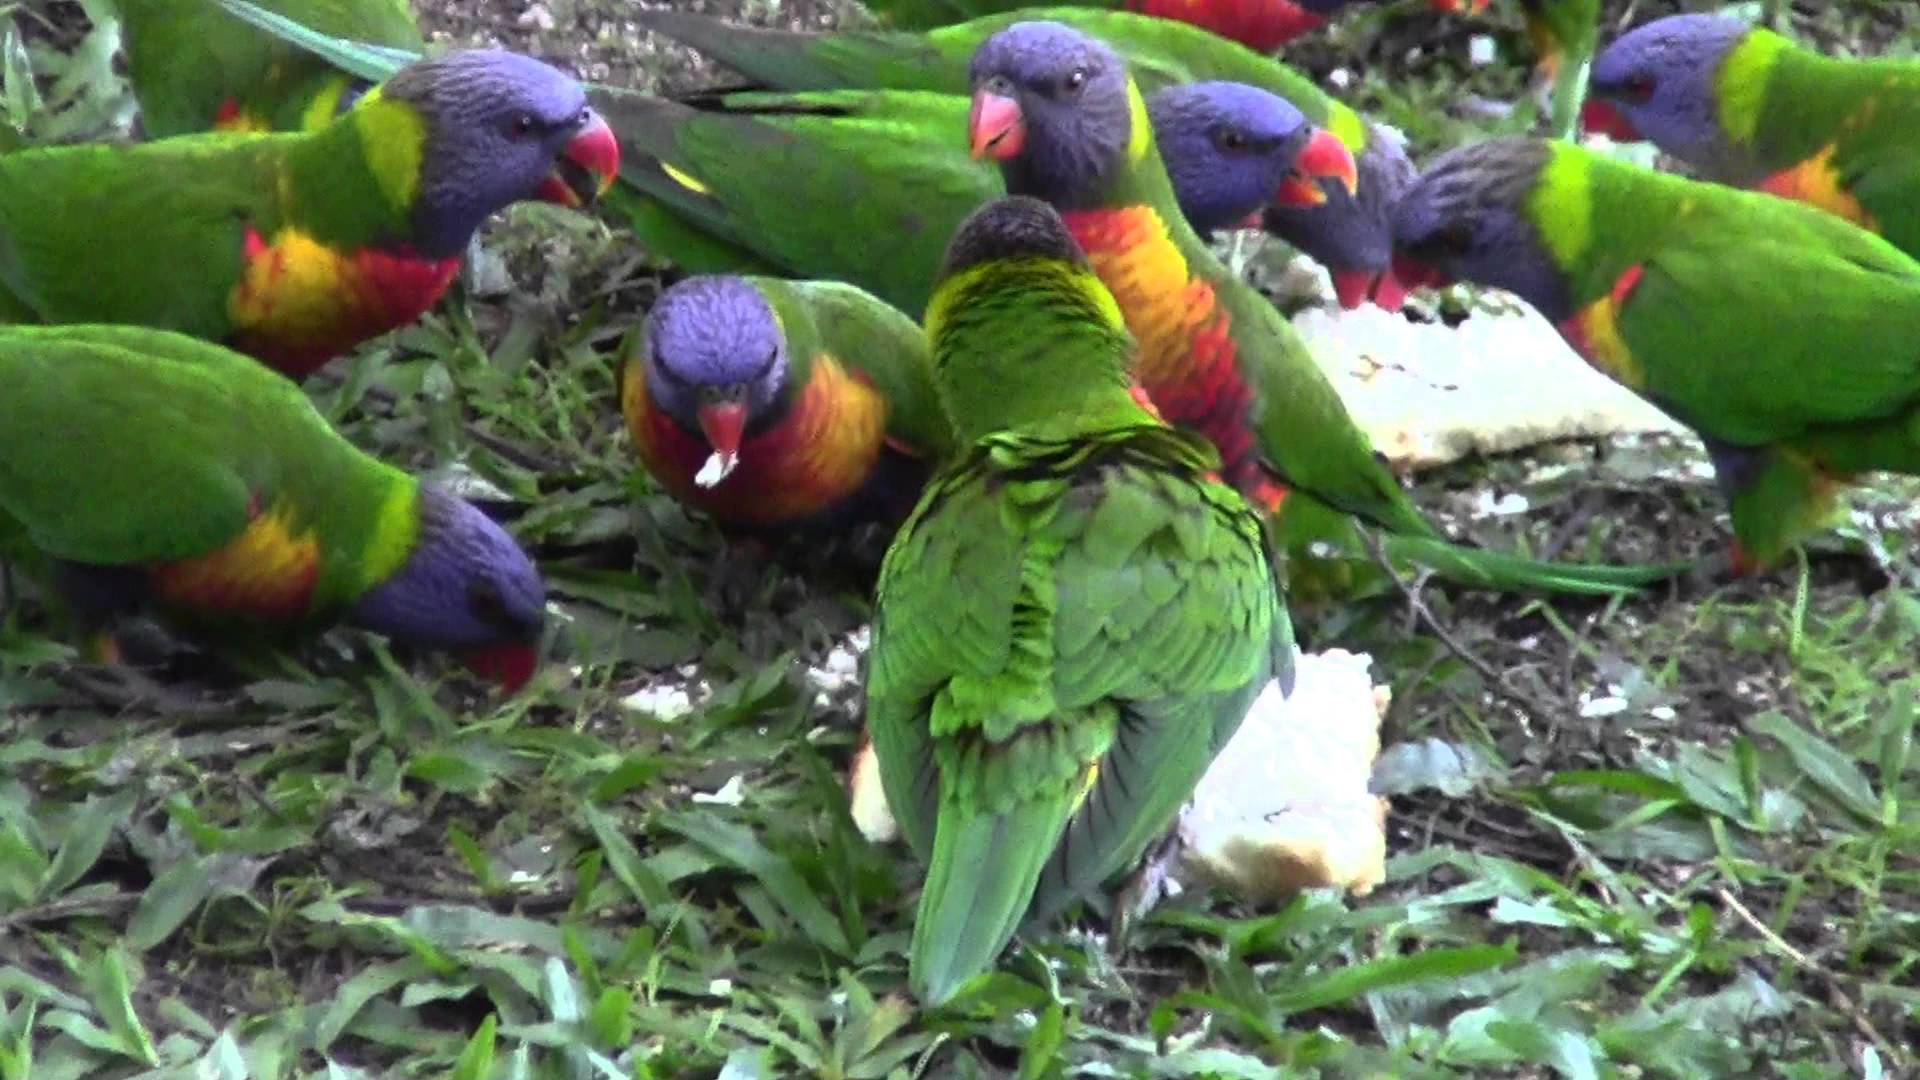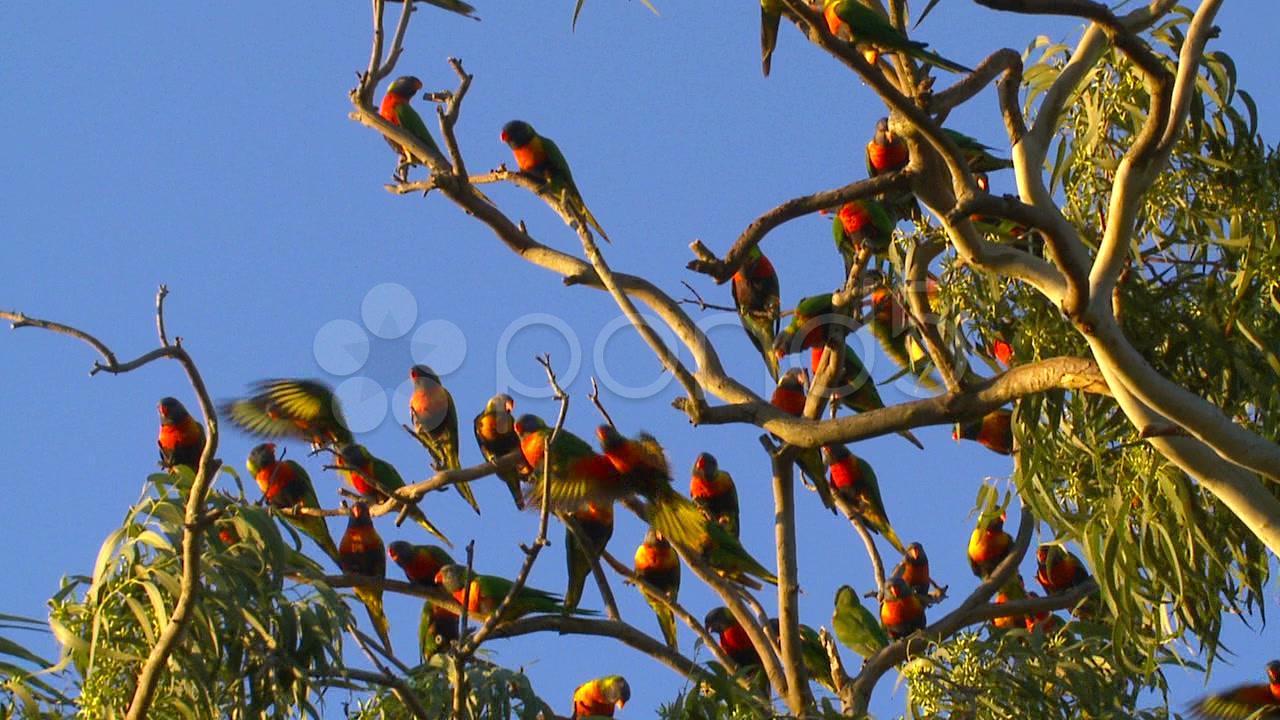The first image is the image on the left, the second image is the image on the right. For the images shown, is this caption "There are at least two birds in the image on the left." true? Answer yes or no. Yes. The first image is the image on the left, the second image is the image on the right. Given the left and right images, does the statement "At least eight colorful birds are gathered together, each having a blue head." hold true? Answer yes or no. Yes. 